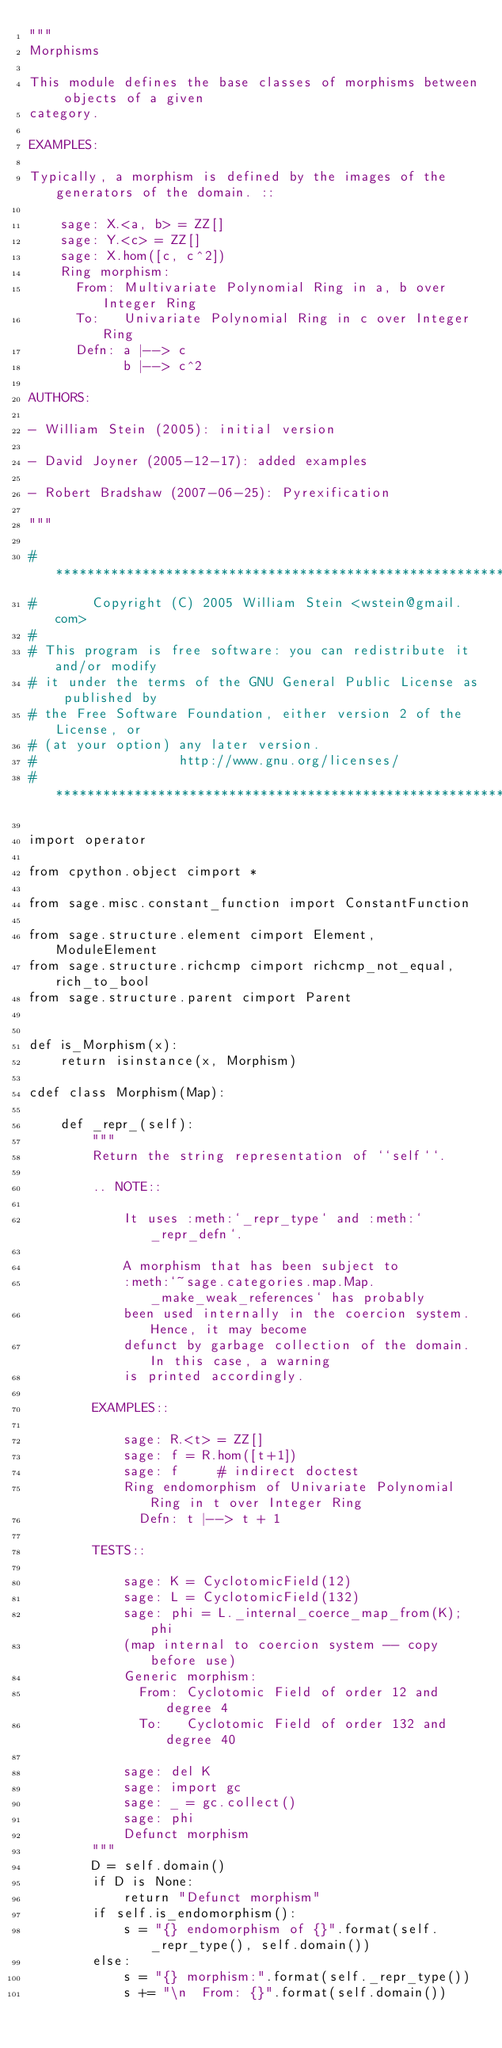<code> <loc_0><loc_0><loc_500><loc_500><_Cython_>"""
Morphisms

This module defines the base classes of morphisms between objects of a given
category.

EXAMPLES:

Typically, a morphism is defined by the images of the generators of the domain. ::

    sage: X.<a, b> = ZZ[]
    sage: Y.<c> = ZZ[]
    sage: X.hom([c, c^2])
    Ring morphism:
      From: Multivariate Polynomial Ring in a, b over Integer Ring
      To:   Univariate Polynomial Ring in c over Integer Ring
      Defn: a |--> c
            b |--> c^2

AUTHORS:

- William Stein (2005): initial version

- David Joyner (2005-12-17): added examples

- Robert Bradshaw (2007-06-25): Pyrexification

"""

#*****************************************************************************
#       Copyright (C) 2005 William Stein <wstein@gmail.com>
#
# This program is free software: you can redistribute it and/or modify
# it under the terms of the GNU General Public License as published by
# the Free Software Foundation, either version 2 of the License, or
# (at your option) any later version.
#                  http://www.gnu.org/licenses/
#*****************************************************************************

import operator

from cpython.object cimport *

from sage.misc.constant_function import ConstantFunction

from sage.structure.element cimport Element, ModuleElement
from sage.structure.richcmp cimport richcmp_not_equal, rich_to_bool
from sage.structure.parent cimport Parent


def is_Morphism(x):
    return isinstance(x, Morphism)

cdef class Morphism(Map):

    def _repr_(self):
        """
        Return the string representation of ``self``.

        .. NOTE::

            It uses :meth:`_repr_type` and :meth:`_repr_defn`.

            A morphism that has been subject to
            :meth:`~sage.categories.map.Map._make_weak_references` has probably
            been used internally in the coercion system. Hence, it may become
            defunct by garbage collection of the domain. In this case, a warning
            is printed accordingly.

        EXAMPLES::

            sage: R.<t> = ZZ[]
            sage: f = R.hom([t+1])
            sage: f     # indirect doctest
            Ring endomorphism of Univariate Polynomial Ring in t over Integer Ring
              Defn: t |--> t + 1

        TESTS::

            sage: K = CyclotomicField(12)
            sage: L = CyclotomicField(132)
            sage: phi = L._internal_coerce_map_from(K); phi
            (map internal to coercion system -- copy before use)
            Generic morphism:
              From: Cyclotomic Field of order 12 and degree 4
              To:   Cyclotomic Field of order 132 and degree 40

            sage: del K
            sage: import gc
            sage: _ = gc.collect()
            sage: phi
            Defunct morphism
        """
        D = self.domain()
        if D is None:
            return "Defunct morphism"
        if self.is_endomorphism():
            s = "{} endomorphism of {}".format(self._repr_type(), self.domain())
        else:
            s = "{} morphism:".format(self._repr_type())
            s += "\n  From: {}".format(self.domain())</code> 